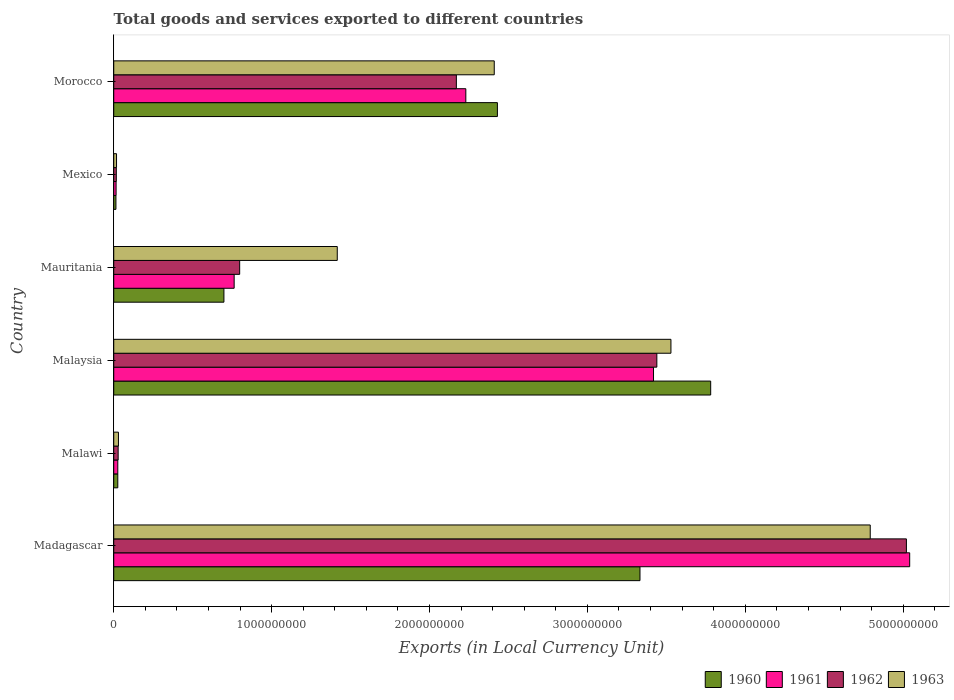How many different coloured bars are there?
Make the answer very short. 4. How many groups of bars are there?
Your response must be concise. 6. Are the number of bars on each tick of the Y-axis equal?
Offer a terse response. Yes. How many bars are there on the 1st tick from the bottom?
Provide a succinct answer. 4. What is the label of the 6th group of bars from the top?
Offer a terse response. Madagascar. What is the Amount of goods and services exports in 1963 in Mauritania?
Your response must be concise. 1.42e+09. Across all countries, what is the maximum Amount of goods and services exports in 1962?
Your answer should be very brief. 5.02e+09. Across all countries, what is the minimum Amount of goods and services exports in 1962?
Your answer should be compact. 1.63e+07. In which country was the Amount of goods and services exports in 1963 maximum?
Keep it short and to the point. Madagascar. In which country was the Amount of goods and services exports in 1963 minimum?
Your answer should be very brief. Mexico. What is the total Amount of goods and services exports in 1963 in the graph?
Offer a very short reply. 1.22e+1. What is the difference between the Amount of goods and services exports in 1962 in Malaysia and that in Mexico?
Your answer should be compact. 3.42e+09. What is the difference between the Amount of goods and services exports in 1963 in Malaysia and the Amount of goods and services exports in 1962 in Malawi?
Offer a terse response. 3.50e+09. What is the average Amount of goods and services exports in 1963 per country?
Your response must be concise. 2.03e+09. What is the difference between the Amount of goods and services exports in 1961 and Amount of goods and services exports in 1963 in Mexico?
Give a very brief answer. -2.75e+06. What is the ratio of the Amount of goods and services exports in 1960 in Malaysia to that in Morocco?
Keep it short and to the point. 1.56. Is the Amount of goods and services exports in 1960 in Madagascar less than that in Mexico?
Offer a very short reply. No. What is the difference between the highest and the second highest Amount of goods and services exports in 1961?
Ensure brevity in your answer.  1.62e+09. What is the difference between the highest and the lowest Amount of goods and services exports in 1963?
Your answer should be compact. 4.77e+09. Is the sum of the Amount of goods and services exports in 1960 in Malaysia and Mexico greater than the maximum Amount of goods and services exports in 1961 across all countries?
Your answer should be compact. No. Is it the case that in every country, the sum of the Amount of goods and services exports in 1963 and Amount of goods and services exports in 1962 is greater than the sum of Amount of goods and services exports in 1961 and Amount of goods and services exports in 1960?
Your answer should be very brief. No. What does the 3rd bar from the top in Morocco represents?
Ensure brevity in your answer.  1961. What does the 3rd bar from the bottom in Morocco represents?
Provide a short and direct response. 1962. How many countries are there in the graph?
Provide a succinct answer. 6. Are the values on the major ticks of X-axis written in scientific E-notation?
Offer a terse response. No. Where does the legend appear in the graph?
Ensure brevity in your answer.  Bottom right. What is the title of the graph?
Keep it short and to the point. Total goods and services exported to different countries. What is the label or title of the X-axis?
Keep it short and to the point. Exports (in Local Currency Unit). What is the label or title of the Y-axis?
Your answer should be very brief. Country. What is the Exports (in Local Currency Unit) in 1960 in Madagascar?
Give a very brief answer. 3.33e+09. What is the Exports (in Local Currency Unit) in 1961 in Madagascar?
Your answer should be very brief. 5.04e+09. What is the Exports (in Local Currency Unit) of 1962 in Madagascar?
Offer a terse response. 5.02e+09. What is the Exports (in Local Currency Unit) of 1963 in Madagascar?
Your answer should be compact. 4.79e+09. What is the Exports (in Local Currency Unit) of 1960 in Malawi?
Offer a very short reply. 2.57e+07. What is the Exports (in Local Currency Unit) of 1961 in Malawi?
Your response must be concise. 2.57e+07. What is the Exports (in Local Currency Unit) of 1962 in Malawi?
Offer a terse response. 2.80e+07. What is the Exports (in Local Currency Unit) in 1963 in Malawi?
Your answer should be very brief. 2.98e+07. What is the Exports (in Local Currency Unit) of 1960 in Malaysia?
Give a very brief answer. 3.78e+09. What is the Exports (in Local Currency Unit) in 1961 in Malaysia?
Offer a very short reply. 3.42e+09. What is the Exports (in Local Currency Unit) in 1962 in Malaysia?
Make the answer very short. 3.44e+09. What is the Exports (in Local Currency Unit) of 1963 in Malaysia?
Give a very brief answer. 3.53e+09. What is the Exports (in Local Currency Unit) in 1960 in Mauritania?
Offer a terse response. 6.98e+08. What is the Exports (in Local Currency Unit) in 1961 in Mauritania?
Your answer should be very brief. 7.63e+08. What is the Exports (in Local Currency Unit) in 1962 in Mauritania?
Give a very brief answer. 7.98e+08. What is the Exports (in Local Currency Unit) of 1963 in Mauritania?
Your answer should be compact. 1.42e+09. What is the Exports (in Local Currency Unit) of 1960 in Mexico?
Provide a succinct answer. 1.39e+07. What is the Exports (in Local Currency Unit) of 1961 in Mexico?
Keep it short and to the point. 1.49e+07. What is the Exports (in Local Currency Unit) in 1962 in Mexico?
Ensure brevity in your answer.  1.63e+07. What is the Exports (in Local Currency Unit) of 1963 in Mexico?
Make the answer very short. 1.76e+07. What is the Exports (in Local Currency Unit) in 1960 in Morocco?
Offer a very short reply. 2.43e+09. What is the Exports (in Local Currency Unit) of 1961 in Morocco?
Your answer should be very brief. 2.23e+09. What is the Exports (in Local Currency Unit) in 1962 in Morocco?
Ensure brevity in your answer.  2.17e+09. What is the Exports (in Local Currency Unit) in 1963 in Morocco?
Your answer should be very brief. 2.41e+09. Across all countries, what is the maximum Exports (in Local Currency Unit) in 1960?
Ensure brevity in your answer.  3.78e+09. Across all countries, what is the maximum Exports (in Local Currency Unit) in 1961?
Offer a terse response. 5.04e+09. Across all countries, what is the maximum Exports (in Local Currency Unit) in 1962?
Give a very brief answer. 5.02e+09. Across all countries, what is the maximum Exports (in Local Currency Unit) of 1963?
Give a very brief answer. 4.79e+09. Across all countries, what is the minimum Exports (in Local Currency Unit) in 1960?
Give a very brief answer. 1.39e+07. Across all countries, what is the minimum Exports (in Local Currency Unit) in 1961?
Your response must be concise. 1.49e+07. Across all countries, what is the minimum Exports (in Local Currency Unit) in 1962?
Give a very brief answer. 1.63e+07. Across all countries, what is the minimum Exports (in Local Currency Unit) in 1963?
Keep it short and to the point. 1.76e+07. What is the total Exports (in Local Currency Unit) of 1960 in the graph?
Ensure brevity in your answer.  1.03e+1. What is the total Exports (in Local Currency Unit) of 1961 in the graph?
Offer a terse response. 1.15e+1. What is the total Exports (in Local Currency Unit) of 1962 in the graph?
Give a very brief answer. 1.15e+1. What is the total Exports (in Local Currency Unit) in 1963 in the graph?
Offer a very short reply. 1.22e+1. What is the difference between the Exports (in Local Currency Unit) of 1960 in Madagascar and that in Malawi?
Ensure brevity in your answer.  3.31e+09. What is the difference between the Exports (in Local Currency Unit) in 1961 in Madagascar and that in Malawi?
Provide a short and direct response. 5.02e+09. What is the difference between the Exports (in Local Currency Unit) in 1962 in Madagascar and that in Malawi?
Give a very brief answer. 4.99e+09. What is the difference between the Exports (in Local Currency Unit) in 1963 in Madagascar and that in Malawi?
Ensure brevity in your answer.  4.76e+09. What is the difference between the Exports (in Local Currency Unit) of 1960 in Madagascar and that in Malaysia?
Your answer should be compact. -4.48e+08. What is the difference between the Exports (in Local Currency Unit) of 1961 in Madagascar and that in Malaysia?
Keep it short and to the point. 1.62e+09. What is the difference between the Exports (in Local Currency Unit) in 1962 in Madagascar and that in Malaysia?
Ensure brevity in your answer.  1.58e+09. What is the difference between the Exports (in Local Currency Unit) in 1963 in Madagascar and that in Malaysia?
Provide a short and direct response. 1.26e+09. What is the difference between the Exports (in Local Currency Unit) of 1960 in Madagascar and that in Mauritania?
Your answer should be compact. 2.64e+09. What is the difference between the Exports (in Local Currency Unit) of 1961 in Madagascar and that in Mauritania?
Offer a very short reply. 4.28e+09. What is the difference between the Exports (in Local Currency Unit) of 1962 in Madagascar and that in Mauritania?
Offer a terse response. 4.22e+09. What is the difference between the Exports (in Local Currency Unit) in 1963 in Madagascar and that in Mauritania?
Keep it short and to the point. 3.38e+09. What is the difference between the Exports (in Local Currency Unit) in 1960 in Madagascar and that in Mexico?
Your answer should be compact. 3.32e+09. What is the difference between the Exports (in Local Currency Unit) in 1961 in Madagascar and that in Mexico?
Provide a short and direct response. 5.03e+09. What is the difference between the Exports (in Local Currency Unit) in 1962 in Madagascar and that in Mexico?
Keep it short and to the point. 5.00e+09. What is the difference between the Exports (in Local Currency Unit) of 1963 in Madagascar and that in Mexico?
Make the answer very short. 4.77e+09. What is the difference between the Exports (in Local Currency Unit) in 1960 in Madagascar and that in Morocco?
Ensure brevity in your answer.  9.03e+08. What is the difference between the Exports (in Local Currency Unit) of 1961 in Madagascar and that in Morocco?
Your response must be concise. 2.81e+09. What is the difference between the Exports (in Local Currency Unit) in 1962 in Madagascar and that in Morocco?
Your response must be concise. 2.85e+09. What is the difference between the Exports (in Local Currency Unit) in 1963 in Madagascar and that in Morocco?
Offer a very short reply. 2.38e+09. What is the difference between the Exports (in Local Currency Unit) in 1960 in Malawi and that in Malaysia?
Your answer should be very brief. -3.76e+09. What is the difference between the Exports (in Local Currency Unit) of 1961 in Malawi and that in Malaysia?
Offer a very short reply. -3.39e+09. What is the difference between the Exports (in Local Currency Unit) in 1962 in Malawi and that in Malaysia?
Offer a terse response. -3.41e+09. What is the difference between the Exports (in Local Currency Unit) of 1963 in Malawi and that in Malaysia?
Provide a short and direct response. -3.50e+09. What is the difference between the Exports (in Local Currency Unit) of 1960 in Malawi and that in Mauritania?
Your response must be concise. -6.72e+08. What is the difference between the Exports (in Local Currency Unit) in 1961 in Malawi and that in Mauritania?
Your answer should be very brief. -7.37e+08. What is the difference between the Exports (in Local Currency Unit) in 1962 in Malawi and that in Mauritania?
Give a very brief answer. -7.70e+08. What is the difference between the Exports (in Local Currency Unit) of 1963 in Malawi and that in Mauritania?
Offer a very short reply. -1.39e+09. What is the difference between the Exports (in Local Currency Unit) in 1960 in Malawi and that in Mexico?
Make the answer very short. 1.18e+07. What is the difference between the Exports (in Local Currency Unit) of 1961 in Malawi and that in Mexico?
Provide a short and direct response. 1.08e+07. What is the difference between the Exports (in Local Currency Unit) in 1962 in Malawi and that in Mexico?
Make the answer very short. 1.17e+07. What is the difference between the Exports (in Local Currency Unit) in 1963 in Malawi and that in Mexico?
Keep it short and to the point. 1.22e+07. What is the difference between the Exports (in Local Currency Unit) of 1960 in Malawi and that in Morocco?
Ensure brevity in your answer.  -2.40e+09. What is the difference between the Exports (in Local Currency Unit) of 1961 in Malawi and that in Morocco?
Your response must be concise. -2.20e+09. What is the difference between the Exports (in Local Currency Unit) in 1962 in Malawi and that in Morocco?
Provide a succinct answer. -2.14e+09. What is the difference between the Exports (in Local Currency Unit) in 1963 in Malawi and that in Morocco?
Make the answer very short. -2.38e+09. What is the difference between the Exports (in Local Currency Unit) in 1960 in Malaysia and that in Mauritania?
Offer a very short reply. 3.08e+09. What is the difference between the Exports (in Local Currency Unit) in 1961 in Malaysia and that in Mauritania?
Your answer should be very brief. 2.66e+09. What is the difference between the Exports (in Local Currency Unit) of 1962 in Malaysia and that in Mauritania?
Your answer should be very brief. 2.64e+09. What is the difference between the Exports (in Local Currency Unit) of 1963 in Malaysia and that in Mauritania?
Your answer should be compact. 2.11e+09. What is the difference between the Exports (in Local Currency Unit) of 1960 in Malaysia and that in Mexico?
Offer a terse response. 3.77e+09. What is the difference between the Exports (in Local Currency Unit) in 1961 in Malaysia and that in Mexico?
Your answer should be compact. 3.40e+09. What is the difference between the Exports (in Local Currency Unit) in 1962 in Malaysia and that in Mexico?
Your answer should be very brief. 3.42e+09. What is the difference between the Exports (in Local Currency Unit) of 1963 in Malaysia and that in Mexico?
Your response must be concise. 3.51e+09. What is the difference between the Exports (in Local Currency Unit) in 1960 in Malaysia and that in Morocco?
Keep it short and to the point. 1.35e+09. What is the difference between the Exports (in Local Currency Unit) in 1961 in Malaysia and that in Morocco?
Your response must be concise. 1.19e+09. What is the difference between the Exports (in Local Currency Unit) in 1962 in Malaysia and that in Morocco?
Provide a succinct answer. 1.27e+09. What is the difference between the Exports (in Local Currency Unit) in 1963 in Malaysia and that in Morocco?
Provide a succinct answer. 1.12e+09. What is the difference between the Exports (in Local Currency Unit) of 1960 in Mauritania and that in Mexico?
Ensure brevity in your answer.  6.84e+08. What is the difference between the Exports (in Local Currency Unit) of 1961 in Mauritania and that in Mexico?
Offer a very short reply. 7.48e+08. What is the difference between the Exports (in Local Currency Unit) in 1962 in Mauritania and that in Mexico?
Keep it short and to the point. 7.81e+08. What is the difference between the Exports (in Local Currency Unit) in 1963 in Mauritania and that in Mexico?
Your answer should be compact. 1.40e+09. What is the difference between the Exports (in Local Currency Unit) in 1960 in Mauritania and that in Morocco?
Provide a succinct answer. -1.73e+09. What is the difference between the Exports (in Local Currency Unit) in 1961 in Mauritania and that in Morocco?
Provide a short and direct response. -1.47e+09. What is the difference between the Exports (in Local Currency Unit) of 1962 in Mauritania and that in Morocco?
Your response must be concise. -1.37e+09. What is the difference between the Exports (in Local Currency Unit) of 1963 in Mauritania and that in Morocco?
Offer a terse response. -9.94e+08. What is the difference between the Exports (in Local Currency Unit) in 1960 in Mexico and that in Morocco?
Make the answer very short. -2.42e+09. What is the difference between the Exports (in Local Currency Unit) in 1961 in Mexico and that in Morocco?
Give a very brief answer. -2.22e+09. What is the difference between the Exports (in Local Currency Unit) of 1962 in Mexico and that in Morocco?
Your answer should be compact. -2.15e+09. What is the difference between the Exports (in Local Currency Unit) of 1963 in Mexico and that in Morocco?
Your response must be concise. -2.39e+09. What is the difference between the Exports (in Local Currency Unit) of 1960 in Madagascar and the Exports (in Local Currency Unit) of 1961 in Malawi?
Give a very brief answer. 3.31e+09. What is the difference between the Exports (in Local Currency Unit) of 1960 in Madagascar and the Exports (in Local Currency Unit) of 1962 in Malawi?
Provide a succinct answer. 3.31e+09. What is the difference between the Exports (in Local Currency Unit) of 1960 in Madagascar and the Exports (in Local Currency Unit) of 1963 in Malawi?
Provide a short and direct response. 3.30e+09. What is the difference between the Exports (in Local Currency Unit) in 1961 in Madagascar and the Exports (in Local Currency Unit) in 1962 in Malawi?
Keep it short and to the point. 5.01e+09. What is the difference between the Exports (in Local Currency Unit) of 1961 in Madagascar and the Exports (in Local Currency Unit) of 1963 in Malawi?
Make the answer very short. 5.01e+09. What is the difference between the Exports (in Local Currency Unit) of 1962 in Madagascar and the Exports (in Local Currency Unit) of 1963 in Malawi?
Your answer should be compact. 4.99e+09. What is the difference between the Exports (in Local Currency Unit) in 1960 in Madagascar and the Exports (in Local Currency Unit) in 1961 in Malaysia?
Provide a succinct answer. -8.57e+07. What is the difference between the Exports (in Local Currency Unit) of 1960 in Madagascar and the Exports (in Local Currency Unit) of 1962 in Malaysia?
Offer a very short reply. -1.07e+08. What is the difference between the Exports (in Local Currency Unit) in 1960 in Madagascar and the Exports (in Local Currency Unit) in 1963 in Malaysia?
Offer a terse response. -1.96e+08. What is the difference between the Exports (in Local Currency Unit) of 1961 in Madagascar and the Exports (in Local Currency Unit) of 1962 in Malaysia?
Your response must be concise. 1.60e+09. What is the difference between the Exports (in Local Currency Unit) of 1961 in Madagascar and the Exports (in Local Currency Unit) of 1963 in Malaysia?
Your response must be concise. 1.51e+09. What is the difference between the Exports (in Local Currency Unit) in 1962 in Madagascar and the Exports (in Local Currency Unit) in 1963 in Malaysia?
Offer a terse response. 1.49e+09. What is the difference between the Exports (in Local Currency Unit) of 1960 in Madagascar and the Exports (in Local Currency Unit) of 1961 in Mauritania?
Keep it short and to the point. 2.57e+09. What is the difference between the Exports (in Local Currency Unit) of 1960 in Madagascar and the Exports (in Local Currency Unit) of 1962 in Mauritania?
Your answer should be very brief. 2.54e+09. What is the difference between the Exports (in Local Currency Unit) in 1960 in Madagascar and the Exports (in Local Currency Unit) in 1963 in Mauritania?
Your answer should be very brief. 1.92e+09. What is the difference between the Exports (in Local Currency Unit) of 1961 in Madagascar and the Exports (in Local Currency Unit) of 1962 in Mauritania?
Offer a very short reply. 4.24e+09. What is the difference between the Exports (in Local Currency Unit) in 1961 in Madagascar and the Exports (in Local Currency Unit) in 1963 in Mauritania?
Your answer should be compact. 3.63e+09. What is the difference between the Exports (in Local Currency Unit) in 1962 in Madagascar and the Exports (in Local Currency Unit) in 1963 in Mauritania?
Give a very brief answer. 3.60e+09. What is the difference between the Exports (in Local Currency Unit) in 1960 in Madagascar and the Exports (in Local Currency Unit) in 1961 in Mexico?
Your answer should be very brief. 3.32e+09. What is the difference between the Exports (in Local Currency Unit) in 1960 in Madagascar and the Exports (in Local Currency Unit) in 1962 in Mexico?
Provide a succinct answer. 3.32e+09. What is the difference between the Exports (in Local Currency Unit) in 1960 in Madagascar and the Exports (in Local Currency Unit) in 1963 in Mexico?
Your response must be concise. 3.32e+09. What is the difference between the Exports (in Local Currency Unit) in 1961 in Madagascar and the Exports (in Local Currency Unit) in 1962 in Mexico?
Your response must be concise. 5.02e+09. What is the difference between the Exports (in Local Currency Unit) of 1961 in Madagascar and the Exports (in Local Currency Unit) of 1963 in Mexico?
Give a very brief answer. 5.02e+09. What is the difference between the Exports (in Local Currency Unit) in 1962 in Madagascar and the Exports (in Local Currency Unit) in 1963 in Mexico?
Your response must be concise. 5.00e+09. What is the difference between the Exports (in Local Currency Unit) in 1960 in Madagascar and the Exports (in Local Currency Unit) in 1961 in Morocco?
Provide a succinct answer. 1.10e+09. What is the difference between the Exports (in Local Currency Unit) in 1960 in Madagascar and the Exports (in Local Currency Unit) in 1962 in Morocco?
Your answer should be compact. 1.16e+09. What is the difference between the Exports (in Local Currency Unit) in 1960 in Madagascar and the Exports (in Local Currency Unit) in 1963 in Morocco?
Give a very brief answer. 9.23e+08. What is the difference between the Exports (in Local Currency Unit) in 1961 in Madagascar and the Exports (in Local Currency Unit) in 1962 in Morocco?
Offer a terse response. 2.87e+09. What is the difference between the Exports (in Local Currency Unit) of 1961 in Madagascar and the Exports (in Local Currency Unit) of 1963 in Morocco?
Offer a very short reply. 2.63e+09. What is the difference between the Exports (in Local Currency Unit) in 1962 in Madagascar and the Exports (in Local Currency Unit) in 1963 in Morocco?
Your answer should be compact. 2.61e+09. What is the difference between the Exports (in Local Currency Unit) in 1960 in Malawi and the Exports (in Local Currency Unit) in 1961 in Malaysia?
Provide a succinct answer. -3.39e+09. What is the difference between the Exports (in Local Currency Unit) of 1960 in Malawi and the Exports (in Local Currency Unit) of 1962 in Malaysia?
Keep it short and to the point. -3.41e+09. What is the difference between the Exports (in Local Currency Unit) in 1960 in Malawi and the Exports (in Local Currency Unit) in 1963 in Malaysia?
Your answer should be very brief. -3.50e+09. What is the difference between the Exports (in Local Currency Unit) in 1961 in Malawi and the Exports (in Local Currency Unit) in 1962 in Malaysia?
Offer a terse response. -3.41e+09. What is the difference between the Exports (in Local Currency Unit) of 1961 in Malawi and the Exports (in Local Currency Unit) of 1963 in Malaysia?
Provide a short and direct response. -3.50e+09. What is the difference between the Exports (in Local Currency Unit) of 1962 in Malawi and the Exports (in Local Currency Unit) of 1963 in Malaysia?
Your response must be concise. -3.50e+09. What is the difference between the Exports (in Local Currency Unit) of 1960 in Malawi and the Exports (in Local Currency Unit) of 1961 in Mauritania?
Keep it short and to the point. -7.37e+08. What is the difference between the Exports (in Local Currency Unit) in 1960 in Malawi and the Exports (in Local Currency Unit) in 1962 in Mauritania?
Provide a succinct answer. -7.72e+08. What is the difference between the Exports (in Local Currency Unit) in 1960 in Malawi and the Exports (in Local Currency Unit) in 1963 in Mauritania?
Your answer should be compact. -1.39e+09. What is the difference between the Exports (in Local Currency Unit) in 1961 in Malawi and the Exports (in Local Currency Unit) in 1962 in Mauritania?
Keep it short and to the point. -7.72e+08. What is the difference between the Exports (in Local Currency Unit) of 1961 in Malawi and the Exports (in Local Currency Unit) of 1963 in Mauritania?
Your response must be concise. -1.39e+09. What is the difference between the Exports (in Local Currency Unit) of 1962 in Malawi and the Exports (in Local Currency Unit) of 1963 in Mauritania?
Your answer should be very brief. -1.39e+09. What is the difference between the Exports (in Local Currency Unit) of 1960 in Malawi and the Exports (in Local Currency Unit) of 1961 in Mexico?
Provide a short and direct response. 1.08e+07. What is the difference between the Exports (in Local Currency Unit) of 1960 in Malawi and the Exports (in Local Currency Unit) of 1962 in Mexico?
Make the answer very short. 9.42e+06. What is the difference between the Exports (in Local Currency Unit) of 1960 in Malawi and the Exports (in Local Currency Unit) of 1963 in Mexico?
Offer a very short reply. 8.06e+06. What is the difference between the Exports (in Local Currency Unit) of 1961 in Malawi and the Exports (in Local Currency Unit) of 1962 in Mexico?
Offer a terse response. 9.42e+06. What is the difference between the Exports (in Local Currency Unit) of 1961 in Malawi and the Exports (in Local Currency Unit) of 1963 in Mexico?
Make the answer very short. 8.06e+06. What is the difference between the Exports (in Local Currency Unit) in 1962 in Malawi and the Exports (in Local Currency Unit) in 1963 in Mexico?
Provide a short and direct response. 1.04e+07. What is the difference between the Exports (in Local Currency Unit) in 1960 in Malawi and the Exports (in Local Currency Unit) in 1961 in Morocco?
Make the answer very short. -2.20e+09. What is the difference between the Exports (in Local Currency Unit) of 1960 in Malawi and the Exports (in Local Currency Unit) of 1962 in Morocco?
Ensure brevity in your answer.  -2.14e+09. What is the difference between the Exports (in Local Currency Unit) in 1960 in Malawi and the Exports (in Local Currency Unit) in 1963 in Morocco?
Your answer should be very brief. -2.38e+09. What is the difference between the Exports (in Local Currency Unit) of 1961 in Malawi and the Exports (in Local Currency Unit) of 1962 in Morocco?
Provide a short and direct response. -2.14e+09. What is the difference between the Exports (in Local Currency Unit) of 1961 in Malawi and the Exports (in Local Currency Unit) of 1963 in Morocco?
Your answer should be very brief. -2.38e+09. What is the difference between the Exports (in Local Currency Unit) in 1962 in Malawi and the Exports (in Local Currency Unit) in 1963 in Morocco?
Give a very brief answer. -2.38e+09. What is the difference between the Exports (in Local Currency Unit) of 1960 in Malaysia and the Exports (in Local Currency Unit) of 1961 in Mauritania?
Give a very brief answer. 3.02e+09. What is the difference between the Exports (in Local Currency Unit) of 1960 in Malaysia and the Exports (in Local Currency Unit) of 1962 in Mauritania?
Provide a short and direct response. 2.98e+09. What is the difference between the Exports (in Local Currency Unit) of 1960 in Malaysia and the Exports (in Local Currency Unit) of 1963 in Mauritania?
Give a very brief answer. 2.37e+09. What is the difference between the Exports (in Local Currency Unit) in 1961 in Malaysia and the Exports (in Local Currency Unit) in 1962 in Mauritania?
Provide a succinct answer. 2.62e+09. What is the difference between the Exports (in Local Currency Unit) in 1961 in Malaysia and the Exports (in Local Currency Unit) in 1963 in Mauritania?
Your response must be concise. 2.00e+09. What is the difference between the Exports (in Local Currency Unit) in 1962 in Malaysia and the Exports (in Local Currency Unit) in 1963 in Mauritania?
Your answer should be compact. 2.02e+09. What is the difference between the Exports (in Local Currency Unit) of 1960 in Malaysia and the Exports (in Local Currency Unit) of 1961 in Mexico?
Offer a terse response. 3.77e+09. What is the difference between the Exports (in Local Currency Unit) in 1960 in Malaysia and the Exports (in Local Currency Unit) in 1962 in Mexico?
Give a very brief answer. 3.76e+09. What is the difference between the Exports (in Local Currency Unit) in 1960 in Malaysia and the Exports (in Local Currency Unit) in 1963 in Mexico?
Give a very brief answer. 3.76e+09. What is the difference between the Exports (in Local Currency Unit) in 1961 in Malaysia and the Exports (in Local Currency Unit) in 1962 in Mexico?
Offer a very short reply. 3.40e+09. What is the difference between the Exports (in Local Currency Unit) in 1961 in Malaysia and the Exports (in Local Currency Unit) in 1963 in Mexico?
Provide a succinct answer. 3.40e+09. What is the difference between the Exports (in Local Currency Unit) of 1962 in Malaysia and the Exports (in Local Currency Unit) of 1963 in Mexico?
Your answer should be compact. 3.42e+09. What is the difference between the Exports (in Local Currency Unit) in 1960 in Malaysia and the Exports (in Local Currency Unit) in 1961 in Morocco?
Offer a terse response. 1.55e+09. What is the difference between the Exports (in Local Currency Unit) in 1960 in Malaysia and the Exports (in Local Currency Unit) in 1962 in Morocco?
Your answer should be compact. 1.61e+09. What is the difference between the Exports (in Local Currency Unit) of 1960 in Malaysia and the Exports (in Local Currency Unit) of 1963 in Morocco?
Your response must be concise. 1.37e+09. What is the difference between the Exports (in Local Currency Unit) in 1961 in Malaysia and the Exports (in Local Currency Unit) in 1962 in Morocco?
Provide a succinct answer. 1.25e+09. What is the difference between the Exports (in Local Currency Unit) of 1961 in Malaysia and the Exports (in Local Currency Unit) of 1963 in Morocco?
Provide a succinct answer. 1.01e+09. What is the difference between the Exports (in Local Currency Unit) in 1962 in Malaysia and the Exports (in Local Currency Unit) in 1963 in Morocco?
Make the answer very short. 1.03e+09. What is the difference between the Exports (in Local Currency Unit) of 1960 in Mauritania and the Exports (in Local Currency Unit) of 1961 in Mexico?
Make the answer very short. 6.83e+08. What is the difference between the Exports (in Local Currency Unit) in 1960 in Mauritania and the Exports (in Local Currency Unit) in 1962 in Mexico?
Your response must be concise. 6.82e+08. What is the difference between the Exports (in Local Currency Unit) in 1960 in Mauritania and the Exports (in Local Currency Unit) in 1963 in Mexico?
Provide a succinct answer. 6.80e+08. What is the difference between the Exports (in Local Currency Unit) in 1961 in Mauritania and the Exports (in Local Currency Unit) in 1962 in Mexico?
Make the answer very short. 7.46e+08. What is the difference between the Exports (in Local Currency Unit) in 1961 in Mauritania and the Exports (in Local Currency Unit) in 1963 in Mexico?
Your answer should be very brief. 7.45e+08. What is the difference between the Exports (in Local Currency Unit) in 1962 in Mauritania and the Exports (in Local Currency Unit) in 1963 in Mexico?
Your response must be concise. 7.80e+08. What is the difference between the Exports (in Local Currency Unit) in 1960 in Mauritania and the Exports (in Local Currency Unit) in 1961 in Morocco?
Make the answer very short. -1.53e+09. What is the difference between the Exports (in Local Currency Unit) in 1960 in Mauritania and the Exports (in Local Currency Unit) in 1962 in Morocco?
Offer a terse response. -1.47e+09. What is the difference between the Exports (in Local Currency Unit) in 1960 in Mauritania and the Exports (in Local Currency Unit) in 1963 in Morocco?
Keep it short and to the point. -1.71e+09. What is the difference between the Exports (in Local Currency Unit) of 1961 in Mauritania and the Exports (in Local Currency Unit) of 1962 in Morocco?
Your answer should be very brief. -1.41e+09. What is the difference between the Exports (in Local Currency Unit) in 1961 in Mauritania and the Exports (in Local Currency Unit) in 1963 in Morocco?
Provide a short and direct response. -1.65e+09. What is the difference between the Exports (in Local Currency Unit) of 1962 in Mauritania and the Exports (in Local Currency Unit) of 1963 in Morocco?
Give a very brief answer. -1.61e+09. What is the difference between the Exports (in Local Currency Unit) in 1960 in Mexico and the Exports (in Local Currency Unit) in 1961 in Morocco?
Your answer should be compact. -2.22e+09. What is the difference between the Exports (in Local Currency Unit) of 1960 in Mexico and the Exports (in Local Currency Unit) of 1962 in Morocco?
Provide a succinct answer. -2.16e+09. What is the difference between the Exports (in Local Currency Unit) of 1960 in Mexico and the Exports (in Local Currency Unit) of 1963 in Morocco?
Keep it short and to the point. -2.40e+09. What is the difference between the Exports (in Local Currency Unit) of 1961 in Mexico and the Exports (in Local Currency Unit) of 1962 in Morocco?
Ensure brevity in your answer.  -2.16e+09. What is the difference between the Exports (in Local Currency Unit) in 1961 in Mexico and the Exports (in Local Currency Unit) in 1963 in Morocco?
Provide a succinct answer. -2.40e+09. What is the difference between the Exports (in Local Currency Unit) of 1962 in Mexico and the Exports (in Local Currency Unit) of 1963 in Morocco?
Keep it short and to the point. -2.39e+09. What is the average Exports (in Local Currency Unit) of 1960 per country?
Your answer should be very brief. 1.71e+09. What is the average Exports (in Local Currency Unit) in 1961 per country?
Offer a terse response. 1.92e+09. What is the average Exports (in Local Currency Unit) of 1962 per country?
Your response must be concise. 1.91e+09. What is the average Exports (in Local Currency Unit) in 1963 per country?
Ensure brevity in your answer.  2.03e+09. What is the difference between the Exports (in Local Currency Unit) of 1960 and Exports (in Local Currency Unit) of 1961 in Madagascar?
Give a very brief answer. -1.71e+09. What is the difference between the Exports (in Local Currency Unit) of 1960 and Exports (in Local Currency Unit) of 1962 in Madagascar?
Give a very brief answer. -1.69e+09. What is the difference between the Exports (in Local Currency Unit) in 1960 and Exports (in Local Currency Unit) in 1963 in Madagascar?
Provide a succinct answer. -1.46e+09. What is the difference between the Exports (in Local Currency Unit) in 1961 and Exports (in Local Currency Unit) in 1962 in Madagascar?
Provide a succinct answer. 2.08e+07. What is the difference between the Exports (in Local Currency Unit) of 1961 and Exports (in Local Currency Unit) of 1963 in Madagascar?
Provide a short and direct response. 2.50e+08. What is the difference between the Exports (in Local Currency Unit) in 1962 and Exports (in Local Currency Unit) in 1963 in Madagascar?
Your answer should be very brief. 2.29e+08. What is the difference between the Exports (in Local Currency Unit) of 1960 and Exports (in Local Currency Unit) of 1961 in Malawi?
Give a very brief answer. 0. What is the difference between the Exports (in Local Currency Unit) in 1960 and Exports (in Local Currency Unit) in 1962 in Malawi?
Provide a succinct answer. -2.30e+06. What is the difference between the Exports (in Local Currency Unit) in 1960 and Exports (in Local Currency Unit) in 1963 in Malawi?
Offer a terse response. -4.10e+06. What is the difference between the Exports (in Local Currency Unit) of 1961 and Exports (in Local Currency Unit) of 1962 in Malawi?
Keep it short and to the point. -2.30e+06. What is the difference between the Exports (in Local Currency Unit) of 1961 and Exports (in Local Currency Unit) of 1963 in Malawi?
Make the answer very short. -4.10e+06. What is the difference between the Exports (in Local Currency Unit) of 1962 and Exports (in Local Currency Unit) of 1963 in Malawi?
Make the answer very short. -1.80e+06. What is the difference between the Exports (in Local Currency Unit) of 1960 and Exports (in Local Currency Unit) of 1961 in Malaysia?
Your answer should be compact. 3.62e+08. What is the difference between the Exports (in Local Currency Unit) of 1960 and Exports (in Local Currency Unit) of 1962 in Malaysia?
Offer a very short reply. 3.41e+08. What is the difference between the Exports (in Local Currency Unit) of 1960 and Exports (in Local Currency Unit) of 1963 in Malaysia?
Your answer should be very brief. 2.52e+08. What is the difference between the Exports (in Local Currency Unit) in 1961 and Exports (in Local Currency Unit) in 1962 in Malaysia?
Keep it short and to the point. -2.11e+07. What is the difference between the Exports (in Local Currency Unit) in 1961 and Exports (in Local Currency Unit) in 1963 in Malaysia?
Give a very brief answer. -1.10e+08. What is the difference between the Exports (in Local Currency Unit) of 1962 and Exports (in Local Currency Unit) of 1963 in Malaysia?
Provide a short and direct response. -8.93e+07. What is the difference between the Exports (in Local Currency Unit) of 1960 and Exports (in Local Currency Unit) of 1961 in Mauritania?
Offer a terse response. -6.48e+07. What is the difference between the Exports (in Local Currency Unit) of 1960 and Exports (in Local Currency Unit) of 1962 in Mauritania?
Your response must be concise. -9.97e+07. What is the difference between the Exports (in Local Currency Unit) in 1960 and Exports (in Local Currency Unit) in 1963 in Mauritania?
Provide a succinct answer. -7.18e+08. What is the difference between the Exports (in Local Currency Unit) of 1961 and Exports (in Local Currency Unit) of 1962 in Mauritania?
Keep it short and to the point. -3.49e+07. What is the difference between the Exports (in Local Currency Unit) of 1961 and Exports (in Local Currency Unit) of 1963 in Mauritania?
Make the answer very short. -6.53e+08. What is the difference between the Exports (in Local Currency Unit) in 1962 and Exports (in Local Currency Unit) in 1963 in Mauritania?
Offer a terse response. -6.18e+08. What is the difference between the Exports (in Local Currency Unit) of 1960 and Exports (in Local Currency Unit) of 1961 in Mexico?
Your answer should be compact. -1.03e+06. What is the difference between the Exports (in Local Currency Unit) of 1960 and Exports (in Local Currency Unit) of 1962 in Mexico?
Offer a terse response. -2.42e+06. What is the difference between the Exports (in Local Currency Unit) of 1960 and Exports (in Local Currency Unit) of 1963 in Mexico?
Provide a short and direct response. -3.77e+06. What is the difference between the Exports (in Local Currency Unit) in 1961 and Exports (in Local Currency Unit) in 1962 in Mexico?
Provide a short and direct response. -1.39e+06. What is the difference between the Exports (in Local Currency Unit) of 1961 and Exports (in Local Currency Unit) of 1963 in Mexico?
Offer a terse response. -2.75e+06. What is the difference between the Exports (in Local Currency Unit) of 1962 and Exports (in Local Currency Unit) of 1963 in Mexico?
Keep it short and to the point. -1.36e+06. What is the difference between the Exports (in Local Currency Unit) in 1960 and Exports (in Local Currency Unit) in 1962 in Morocco?
Give a very brief answer. 2.60e+08. What is the difference between the Exports (in Local Currency Unit) of 1961 and Exports (in Local Currency Unit) of 1962 in Morocco?
Ensure brevity in your answer.  6.00e+07. What is the difference between the Exports (in Local Currency Unit) of 1961 and Exports (in Local Currency Unit) of 1963 in Morocco?
Your answer should be compact. -1.80e+08. What is the difference between the Exports (in Local Currency Unit) in 1962 and Exports (in Local Currency Unit) in 1963 in Morocco?
Keep it short and to the point. -2.40e+08. What is the ratio of the Exports (in Local Currency Unit) of 1960 in Madagascar to that in Malawi?
Provide a succinct answer. 129.69. What is the ratio of the Exports (in Local Currency Unit) in 1961 in Madagascar to that in Malawi?
Provide a short and direct response. 196.16. What is the ratio of the Exports (in Local Currency Unit) of 1962 in Madagascar to that in Malawi?
Provide a short and direct response. 179.3. What is the ratio of the Exports (in Local Currency Unit) of 1963 in Madagascar to that in Malawi?
Your response must be concise. 160.78. What is the ratio of the Exports (in Local Currency Unit) of 1960 in Madagascar to that in Malaysia?
Give a very brief answer. 0.88. What is the ratio of the Exports (in Local Currency Unit) in 1961 in Madagascar to that in Malaysia?
Provide a short and direct response. 1.47. What is the ratio of the Exports (in Local Currency Unit) in 1962 in Madagascar to that in Malaysia?
Your answer should be very brief. 1.46. What is the ratio of the Exports (in Local Currency Unit) in 1963 in Madagascar to that in Malaysia?
Keep it short and to the point. 1.36. What is the ratio of the Exports (in Local Currency Unit) of 1960 in Madagascar to that in Mauritania?
Your answer should be compact. 4.78. What is the ratio of the Exports (in Local Currency Unit) of 1961 in Madagascar to that in Mauritania?
Provide a short and direct response. 6.61. What is the ratio of the Exports (in Local Currency Unit) of 1962 in Madagascar to that in Mauritania?
Keep it short and to the point. 6.29. What is the ratio of the Exports (in Local Currency Unit) of 1963 in Madagascar to that in Mauritania?
Keep it short and to the point. 3.38. What is the ratio of the Exports (in Local Currency Unit) in 1960 in Madagascar to that in Mexico?
Give a very brief answer. 240.41. What is the ratio of the Exports (in Local Currency Unit) in 1961 in Madagascar to that in Mexico?
Ensure brevity in your answer.  338.57. What is the ratio of the Exports (in Local Currency Unit) in 1962 in Madagascar to that in Mexico?
Your answer should be compact. 308.36. What is the ratio of the Exports (in Local Currency Unit) in 1963 in Madagascar to that in Mexico?
Ensure brevity in your answer.  271.64. What is the ratio of the Exports (in Local Currency Unit) in 1960 in Madagascar to that in Morocco?
Provide a short and direct response. 1.37. What is the ratio of the Exports (in Local Currency Unit) of 1961 in Madagascar to that in Morocco?
Offer a very short reply. 2.26. What is the ratio of the Exports (in Local Currency Unit) of 1962 in Madagascar to that in Morocco?
Provide a short and direct response. 2.31. What is the ratio of the Exports (in Local Currency Unit) in 1963 in Madagascar to that in Morocco?
Give a very brief answer. 1.99. What is the ratio of the Exports (in Local Currency Unit) of 1960 in Malawi to that in Malaysia?
Your answer should be very brief. 0.01. What is the ratio of the Exports (in Local Currency Unit) in 1961 in Malawi to that in Malaysia?
Provide a succinct answer. 0.01. What is the ratio of the Exports (in Local Currency Unit) in 1962 in Malawi to that in Malaysia?
Ensure brevity in your answer.  0.01. What is the ratio of the Exports (in Local Currency Unit) in 1963 in Malawi to that in Malaysia?
Your answer should be compact. 0.01. What is the ratio of the Exports (in Local Currency Unit) in 1960 in Malawi to that in Mauritania?
Ensure brevity in your answer.  0.04. What is the ratio of the Exports (in Local Currency Unit) in 1961 in Malawi to that in Mauritania?
Keep it short and to the point. 0.03. What is the ratio of the Exports (in Local Currency Unit) in 1962 in Malawi to that in Mauritania?
Offer a terse response. 0.04. What is the ratio of the Exports (in Local Currency Unit) of 1963 in Malawi to that in Mauritania?
Your answer should be very brief. 0.02. What is the ratio of the Exports (in Local Currency Unit) of 1960 in Malawi to that in Mexico?
Make the answer very short. 1.85. What is the ratio of the Exports (in Local Currency Unit) in 1961 in Malawi to that in Mexico?
Offer a very short reply. 1.73. What is the ratio of the Exports (in Local Currency Unit) in 1962 in Malawi to that in Mexico?
Keep it short and to the point. 1.72. What is the ratio of the Exports (in Local Currency Unit) of 1963 in Malawi to that in Mexico?
Offer a terse response. 1.69. What is the ratio of the Exports (in Local Currency Unit) in 1960 in Malawi to that in Morocco?
Make the answer very short. 0.01. What is the ratio of the Exports (in Local Currency Unit) in 1961 in Malawi to that in Morocco?
Offer a terse response. 0.01. What is the ratio of the Exports (in Local Currency Unit) in 1962 in Malawi to that in Morocco?
Provide a succinct answer. 0.01. What is the ratio of the Exports (in Local Currency Unit) in 1963 in Malawi to that in Morocco?
Provide a short and direct response. 0.01. What is the ratio of the Exports (in Local Currency Unit) of 1960 in Malaysia to that in Mauritania?
Make the answer very short. 5.42. What is the ratio of the Exports (in Local Currency Unit) in 1961 in Malaysia to that in Mauritania?
Provide a succinct answer. 4.48. What is the ratio of the Exports (in Local Currency Unit) in 1962 in Malaysia to that in Mauritania?
Offer a terse response. 4.31. What is the ratio of the Exports (in Local Currency Unit) in 1963 in Malaysia to that in Mauritania?
Provide a succinct answer. 2.49. What is the ratio of the Exports (in Local Currency Unit) of 1960 in Malaysia to that in Mexico?
Your response must be concise. 272.71. What is the ratio of the Exports (in Local Currency Unit) of 1961 in Malaysia to that in Mexico?
Provide a short and direct response. 229.6. What is the ratio of the Exports (in Local Currency Unit) of 1962 in Malaysia to that in Mexico?
Offer a terse response. 211.27. What is the ratio of the Exports (in Local Currency Unit) of 1963 in Malaysia to that in Mexico?
Offer a terse response. 200.08. What is the ratio of the Exports (in Local Currency Unit) of 1960 in Malaysia to that in Morocco?
Your answer should be very brief. 1.56. What is the ratio of the Exports (in Local Currency Unit) in 1961 in Malaysia to that in Morocco?
Your response must be concise. 1.53. What is the ratio of the Exports (in Local Currency Unit) of 1962 in Malaysia to that in Morocco?
Your answer should be very brief. 1.59. What is the ratio of the Exports (in Local Currency Unit) of 1963 in Malaysia to that in Morocco?
Keep it short and to the point. 1.46. What is the ratio of the Exports (in Local Currency Unit) in 1960 in Mauritania to that in Mexico?
Provide a short and direct response. 50.34. What is the ratio of the Exports (in Local Currency Unit) of 1961 in Mauritania to that in Mexico?
Give a very brief answer. 51.22. What is the ratio of the Exports (in Local Currency Unit) in 1962 in Mauritania to that in Mexico?
Keep it short and to the point. 48.99. What is the ratio of the Exports (in Local Currency Unit) of 1963 in Mauritania to that in Mexico?
Offer a very short reply. 80.26. What is the ratio of the Exports (in Local Currency Unit) of 1960 in Mauritania to that in Morocco?
Offer a very short reply. 0.29. What is the ratio of the Exports (in Local Currency Unit) in 1961 in Mauritania to that in Morocco?
Your answer should be very brief. 0.34. What is the ratio of the Exports (in Local Currency Unit) of 1962 in Mauritania to that in Morocco?
Provide a short and direct response. 0.37. What is the ratio of the Exports (in Local Currency Unit) of 1963 in Mauritania to that in Morocco?
Your answer should be very brief. 0.59. What is the ratio of the Exports (in Local Currency Unit) of 1960 in Mexico to that in Morocco?
Your answer should be very brief. 0.01. What is the ratio of the Exports (in Local Currency Unit) of 1961 in Mexico to that in Morocco?
Make the answer very short. 0.01. What is the ratio of the Exports (in Local Currency Unit) of 1962 in Mexico to that in Morocco?
Make the answer very short. 0.01. What is the ratio of the Exports (in Local Currency Unit) in 1963 in Mexico to that in Morocco?
Keep it short and to the point. 0.01. What is the difference between the highest and the second highest Exports (in Local Currency Unit) of 1960?
Provide a short and direct response. 4.48e+08. What is the difference between the highest and the second highest Exports (in Local Currency Unit) in 1961?
Provide a short and direct response. 1.62e+09. What is the difference between the highest and the second highest Exports (in Local Currency Unit) in 1962?
Your answer should be compact. 1.58e+09. What is the difference between the highest and the second highest Exports (in Local Currency Unit) of 1963?
Offer a terse response. 1.26e+09. What is the difference between the highest and the lowest Exports (in Local Currency Unit) of 1960?
Your answer should be very brief. 3.77e+09. What is the difference between the highest and the lowest Exports (in Local Currency Unit) of 1961?
Your answer should be compact. 5.03e+09. What is the difference between the highest and the lowest Exports (in Local Currency Unit) in 1962?
Offer a terse response. 5.00e+09. What is the difference between the highest and the lowest Exports (in Local Currency Unit) of 1963?
Your answer should be compact. 4.77e+09. 